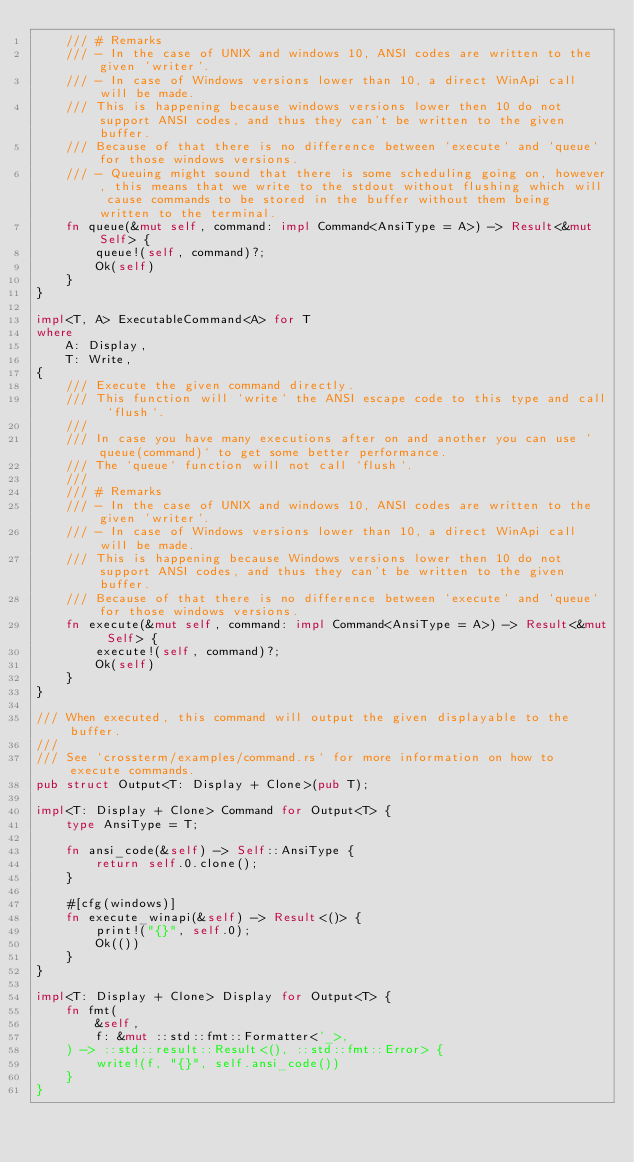<code> <loc_0><loc_0><loc_500><loc_500><_Rust_>    /// # Remarks
    /// - In the case of UNIX and windows 10, ANSI codes are written to the given 'writer'.
    /// - In case of Windows versions lower than 10, a direct WinApi call will be made.
    /// This is happening because windows versions lower then 10 do not support ANSI codes, and thus they can't be written to the given buffer.
    /// Because of that there is no difference between `execute` and `queue` for those windows versions.
    /// - Queuing might sound that there is some scheduling going on, however, this means that we write to the stdout without flushing which will cause commands to be stored in the buffer without them being written to the terminal.
    fn queue(&mut self, command: impl Command<AnsiType = A>) -> Result<&mut Self> {
        queue!(self, command)?;
        Ok(self)
    }
}

impl<T, A> ExecutableCommand<A> for T
where
    A: Display,
    T: Write,
{
    /// Execute the given command directly.
    /// This function will `write` the ANSI escape code to this type and call `flush`.
    ///
    /// In case you have many executions after on and another you can use `queue(command)` to get some better performance.
    /// The `queue` function will not call `flush`.
    ///
    /// # Remarks
    /// - In the case of UNIX and windows 10, ANSI codes are written to the given 'writer'.
    /// - In case of Windows versions lower than 10, a direct WinApi call will be made.
    /// This is happening because Windows versions lower then 10 do not support ANSI codes, and thus they can't be written to the given buffer.
    /// Because of that there is no difference between `execute` and `queue` for those windows versions.
    fn execute(&mut self, command: impl Command<AnsiType = A>) -> Result<&mut Self> {
        execute!(self, command)?;
        Ok(self)
    }
}

/// When executed, this command will output the given displayable to the buffer.
///
/// See `crossterm/examples/command.rs` for more information on how to execute commands.
pub struct Output<T: Display + Clone>(pub T);

impl<T: Display + Clone> Command for Output<T> {
    type AnsiType = T;

    fn ansi_code(&self) -> Self::AnsiType {
        return self.0.clone();
    }

    #[cfg(windows)]
    fn execute_winapi(&self) -> Result<()> {
        print!("{}", self.0);
        Ok(())
    }
}

impl<T: Display + Clone> Display for Output<T> {
    fn fmt(
        &self,
        f: &mut ::std::fmt::Formatter<'_>,
    ) -> ::std::result::Result<(), ::std::fmt::Error> {
        write!(f, "{}", self.ansi_code())
    }
}
</code> 